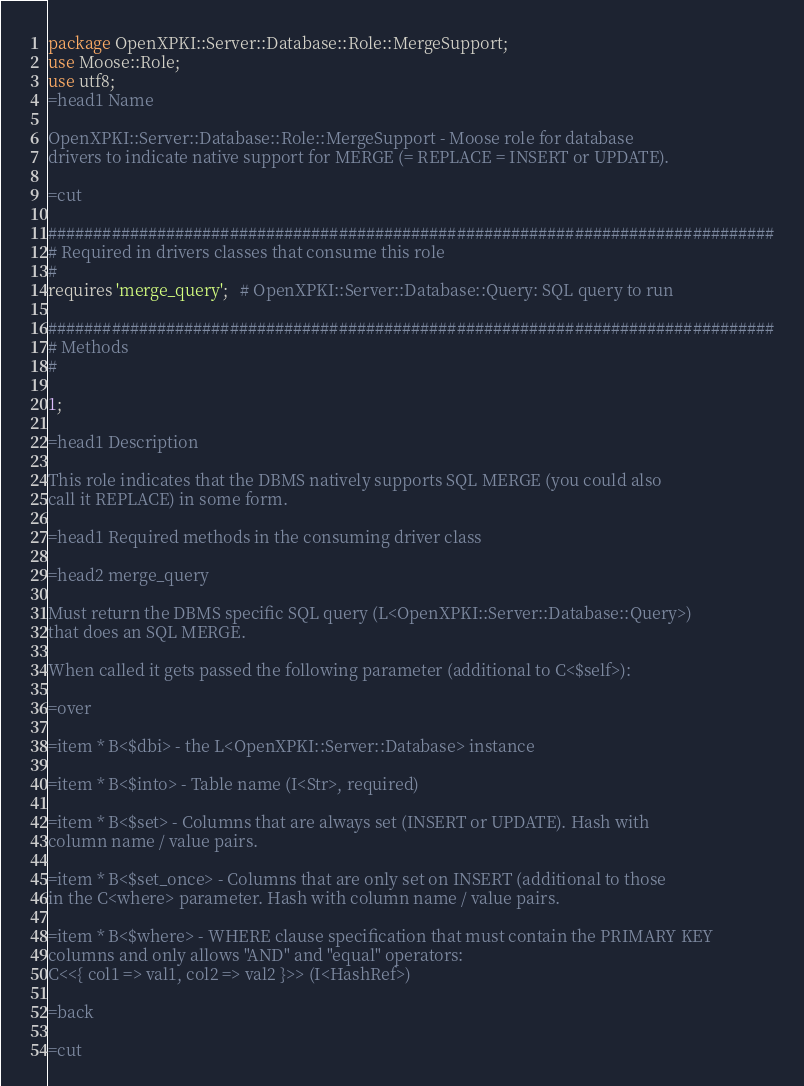<code> <loc_0><loc_0><loc_500><loc_500><_Perl_>package OpenXPKI::Server::Database::Role::MergeSupport;
use Moose::Role;
use utf8;
=head1 Name

OpenXPKI::Server::Database::Role::MergeSupport - Moose role for database
drivers to indicate native support for MERGE (= REPLACE = INSERT or UPDATE).

=cut

################################################################################
# Required in drivers classes that consume this role
#
requires 'merge_query';   # OpenXPKI::Server::Database::Query: SQL query to run

################################################################################
# Methods
#

1;

=head1 Description

This role indicates that the DBMS natively supports SQL MERGE (you could also
call it REPLACE) in some form.

=head1 Required methods in the consuming driver class

=head2 merge_query

Must return the DBMS specific SQL query (L<OpenXPKI::Server::Database::Query>)
that does an SQL MERGE.

When called it gets passed the following parameter (additional to C<$self>):

=over

=item * B<$dbi> - the L<OpenXPKI::Server::Database> instance

=item * B<$into> - Table name (I<Str>, required)

=item * B<$set> - Columns that are always set (INSERT or UPDATE). Hash with
column name / value pairs.

=item * B<$set_once> - Columns that are only set on INSERT (additional to those
in the C<where> parameter. Hash with column name / value pairs.

=item * B<$where> - WHERE clause specification that must contain the PRIMARY KEY
columns and only allows "AND" and "equal" operators:
C<<{ col1 => val1, col2 => val2 }>> (I<HashRef>)

=back

=cut
</code> 